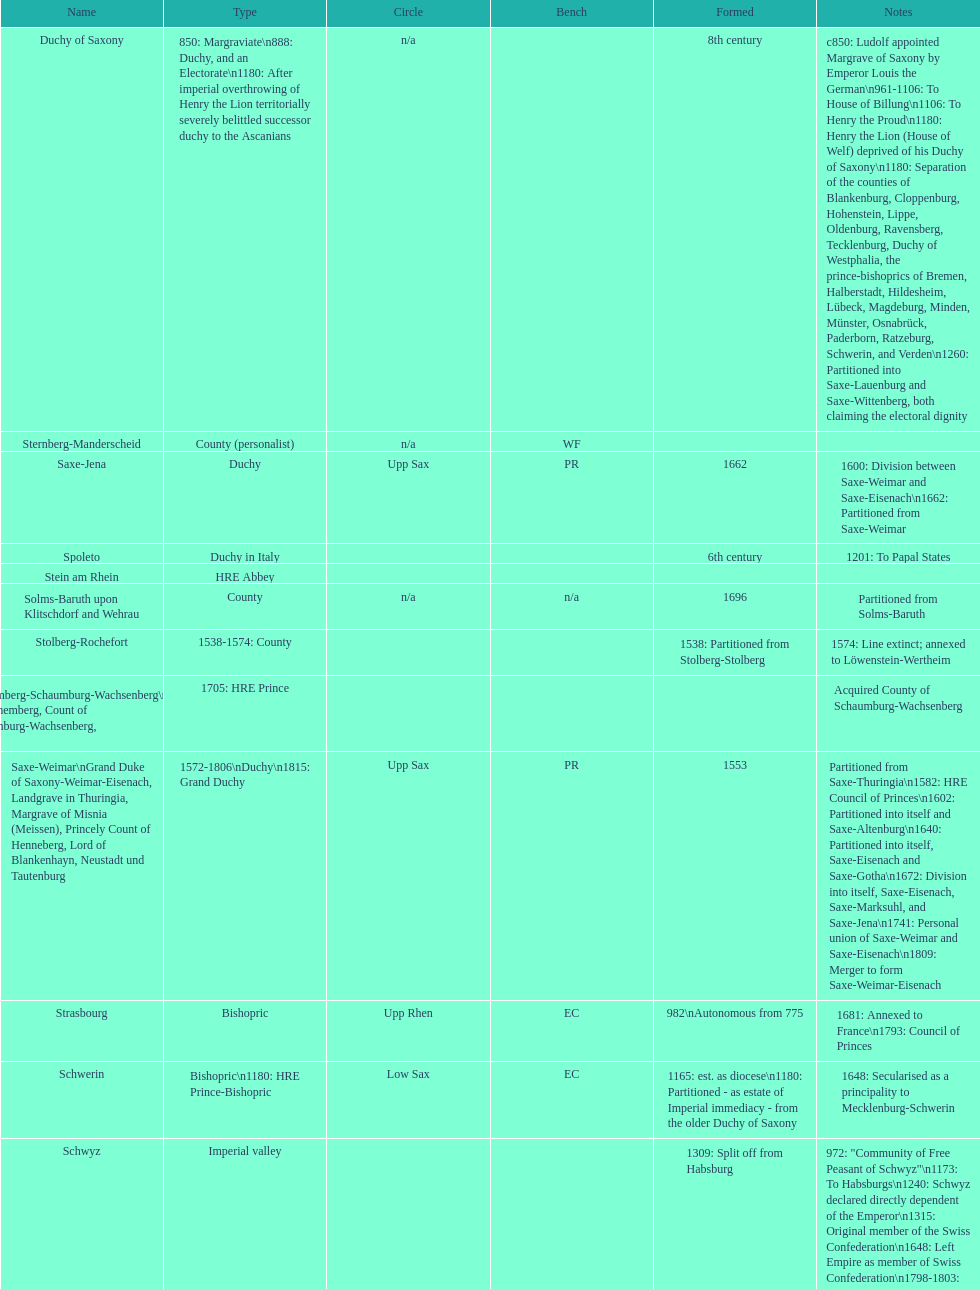How many states were of the same type as stuhlingen? 3. 